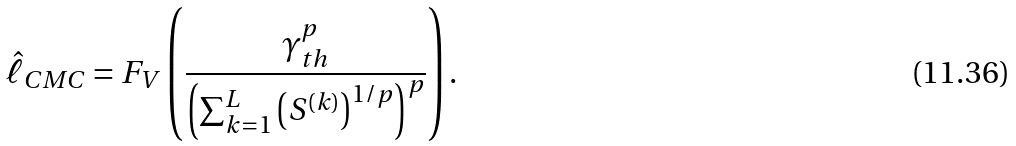<formula> <loc_0><loc_0><loc_500><loc_500>\hat { \ell } _ { C M C } = F _ { V } \left ( \frac { \gamma _ { t h } ^ { p } } { \left ( \sum _ { k = 1 } ^ { L } { \left ( S ^ { ( k ) } \right ) ^ { 1 / p } } \right ) ^ { p } } \right ) .</formula> 